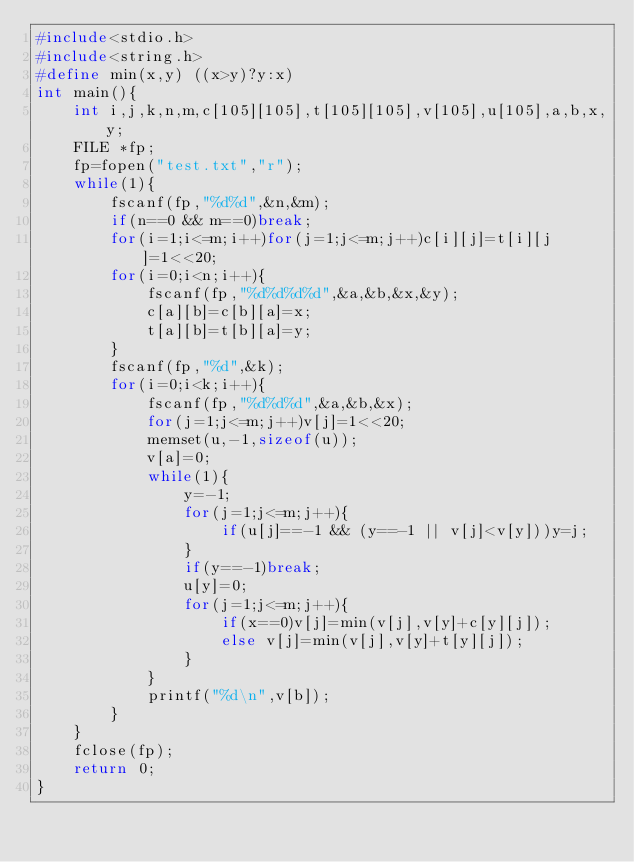<code> <loc_0><loc_0><loc_500><loc_500><_C_>#include<stdio.h>
#include<string.h>
#define min(x,y) ((x>y)?y:x)
int main(){
	int i,j,k,n,m,c[105][105],t[105][105],v[105],u[105],a,b,x,y;
	FILE *fp;
	fp=fopen("test.txt","r");
	while(1){
		fscanf(fp,"%d%d",&n,&m);
		if(n==0 && m==0)break;
		for(i=1;i<=m;i++)for(j=1;j<=m;j++)c[i][j]=t[i][j]=1<<20;
		for(i=0;i<n;i++){
			fscanf(fp,"%d%d%d%d",&a,&b,&x,&y);
			c[a][b]=c[b][a]=x;
			t[a][b]=t[b][a]=y;
		}
		fscanf(fp,"%d",&k);
		for(i=0;i<k;i++){
			fscanf(fp,"%d%d%d",&a,&b,&x);
			for(j=1;j<=m;j++)v[j]=1<<20;
			memset(u,-1,sizeof(u));
			v[a]=0;
			while(1){
				y=-1;
				for(j=1;j<=m;j++){
					if(u[j]==-1 && (y==-1 || v[j]<v[y]))y=j;
				}
				if(y==-1)break;
				u[y]=0;
				for(j=1;j<=m;j++){
					if(x==0)v[j]=min(v[j],v[y]+c[y][j]);
					else v[j]=min(v[j],v[y]+t[y][j]);
				}
			}
			printf("%d\n",v[b]);
		}
	}
	fclose(fp);
	return 0;
}</code> 